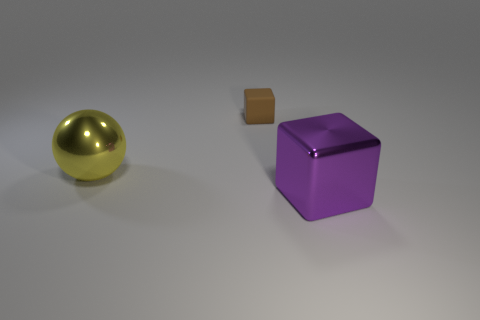What number of things are either metallic things to the right of the brown matte object or small rubber cubes?
Your response must be concise. 2. What number of large purple metal blocks are there?
Give a very brief answer. 1. There is a object that is the same material as the sphere; what is its shape?
Provide a succinct answer. Cube. How big is the block to the left of the shiny object to the right of the small brown cube?
Keep it short and to the point. Small. How many objects are things that are in front of the tiny brown matte thing or shiny objects that are behind the metal cube?
Make the answer very short. 2. Are there fewer big cyan shiny cubes than large purple metallic cubes?
Your response must be concise. Yes. How many things are large brown cubes or large things?
Give a very brief answer. 2. Is the big yellow thing the same shape as the tiny brown matte object?
Your answer should be compact. No. Is there any other thing that is the same material as the tiny brown thing?
Your answer should be very brief. No. Does the object that is in front of the yellow object have the same size as the cube left of the purple thing?
Ensure brevity in your answer.  No. 